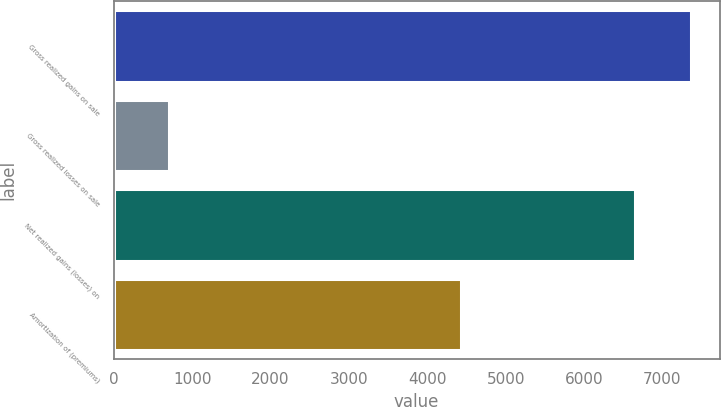Convert chart. <chart><loc_0><loc_0><loc_500><loc_500><bar_chart><fcel>Gross realized gains on sale<fcel>Gross realized losses on sale<fcel>Net realized gains (losses) on<fcel>Amortization of (premiums)<nl><fcel>7360<fcel>710<fcel>6650<fcel>4427<nl></chart> 